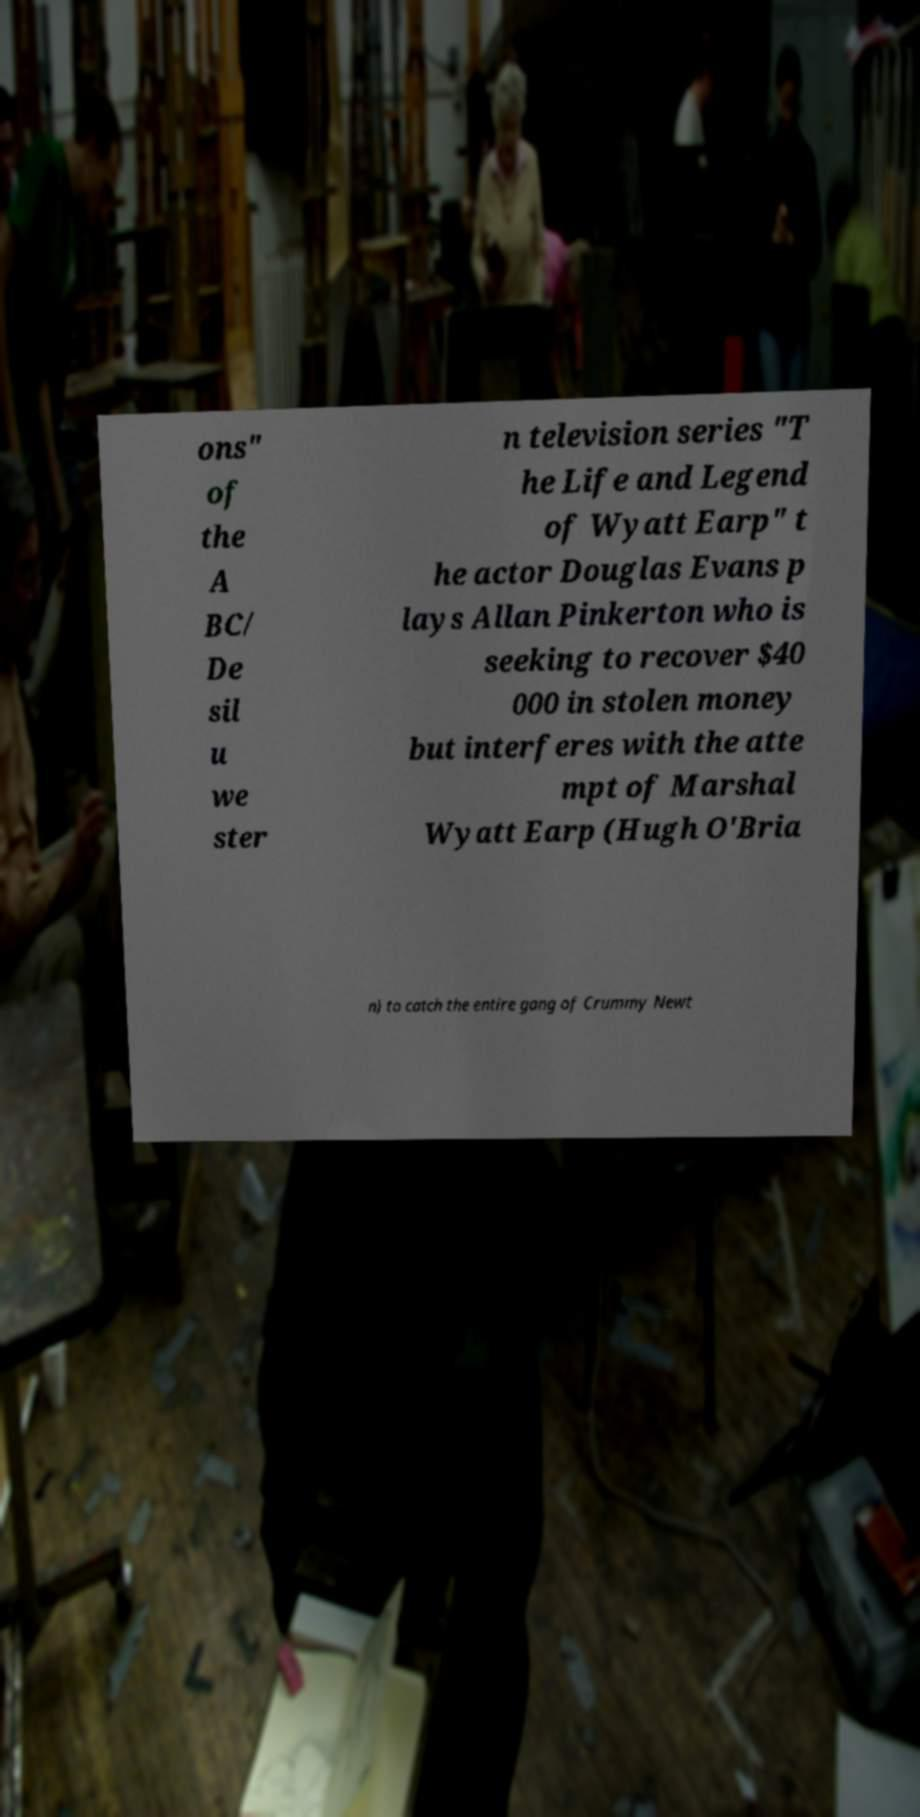What messages or text are displayed in this image? I need them in a readable, typed format. ons" of the A BC/ De sil u we ster n television series "T he Life and Legend of Wyatt Earp" t he actor Douglas Evans p lays Allan Pinkerton who is seeking to recover $40 000 in stolen money but interferes with the atte mpt of Marshal Wyatt Earp (Hugh O'Bria n) to catch the entire gang of Crummy Newt 